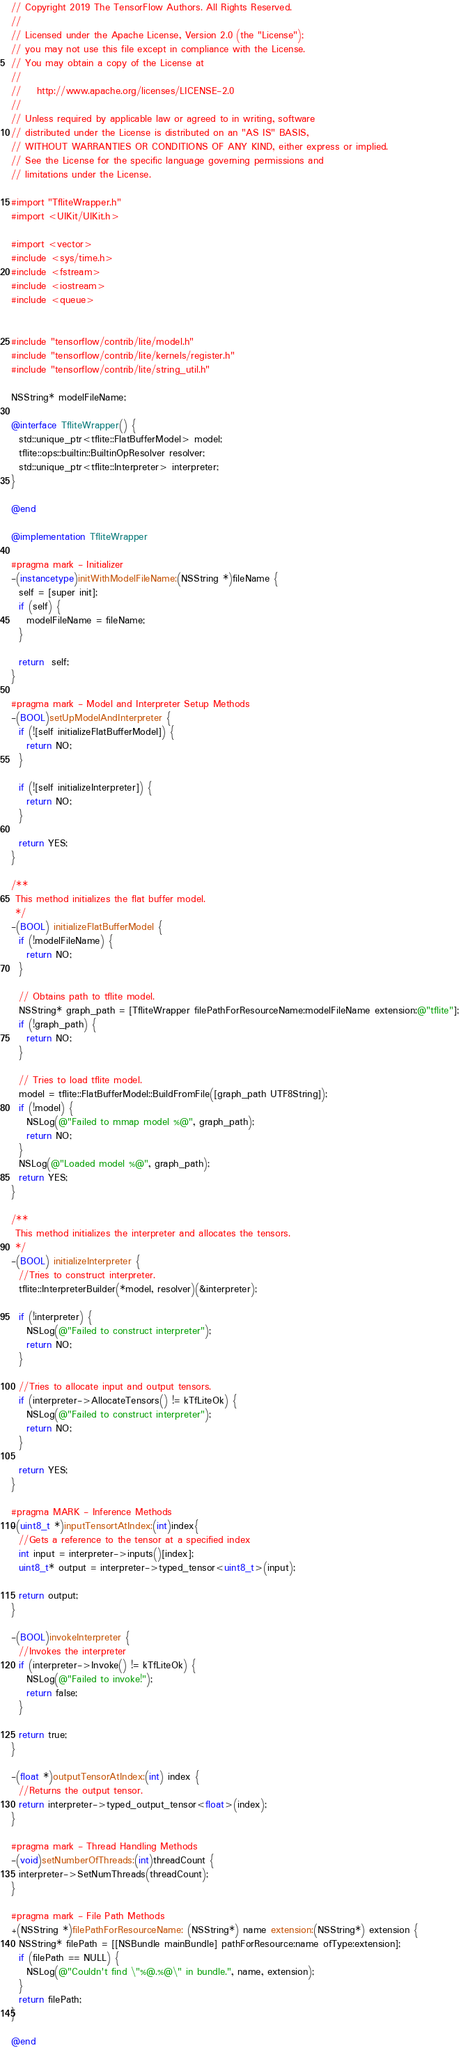Convert code to text. <code><loc_0><loc_0><loc_500><loc_500><_ObjectiveC_>// Copyright 2019 The TensorFlow Authors. All Rights Reserved.
//
// Licensed under the Apache License, Version 2.0 (the "License");
// you may not use this file except in compliance with the License.
// You may obtain a copy of the License at
//
//    http://www.apache.org/licenses/LICENSE-2.0
//
// Unless required by applicable law or agreed to in writing, software
// distributed under the License is distributed on an "AS IS" BASIS,
// WITHOUT WARRANTIES OR CONDITIONS OF ANY KIND, either express or implied.
// See the License for the specific language governing permissions and
// limitations under the License.

#import "TfliteWrapper.h"
#import <UIKit/UIKit.h>

#import <vector>
#include <sys/time.h>
#include <fstream>
#include <iostream>
#include <queue>


#include "tensorflow/contrib/lite/model.h"
#include "tensorflow/contrib/lite/kernels/register.h"
#include "tensorflow/contrib/lite/string_util.h"

NSString* modelFileName;

@interface TfliteWrapper() {
  std::unique_ptr<tflite::FlatBufferModel> model;
  tflite::ops::builtin::BuiltinOpResolver resolver;
  std::unique_ptr<tflite::Interpreter> interpreter;
}

@end

@implementation TfliteWrapper

#pragma mark - Initializer
-(instancetype)initWithModelFileName:(NSString *)fileName {
  self = [super init];
  if (self) {
    modelFileName = fileName;
  }

  return  self;
}

#pragma mark - Model and Interpreter Setup Methods
-(BOOL)setUpModelAndInterpreter {
  if (![self initializeFlatBufferModel]) {
    return NO;
  }

  if (![self initializeInterpreter]) {
    return NO;
  }

  return YES;
}

/**
 This method initializes the flat buffer model.
 */
-(BOOL) initializeFlatBufferModel {
  if (!modelFileName) {
    return NO;
  }

  // Obtains path to tflite model.
  NSString* graph_path = [TfliteWrapper filePathForResourceName:modelFileName extension:@"tflite"];
  if (!graph_path) {
    return NO;
  }

  // Tries to load tflite model.
  model = tflite::FlatBufferModel::BuildFromFile([graph_path UTF8String]);
  if (!model) {
    NSLog(@"Failed to mmap model %@", graph_path);
    return NO;
  }
  NSLog(@"Loaded model %@", graph_path);
  return YES;
}

/**
 This method initializes the interpreter and allocates the tensors.
 */
-(BOOL) initializeInterpreter {
  //Tries to construct interpreter.
  tflite::InterpreterBuilder(*model, resolver)(&interpreter);

  if (!interpreter) {
    NSLog(@"Failed to construct interpreter");
    return NO;
  }

  //Tries to allocate input and output tensors.
  if (interpreter->AllocateTensors() != kTfLiteOk) {
    NSLog(@"Failed to construct interpreter");
    return NO;
  }

  return YES;
}

#pragma MARK - Inference Methods
-(uint8_t *)inputTensortAtIndex:(int)index{
  //Gets a reference to the tensor at a specified index
  int input = interpreter->inputs()[index];
  uint8_t* output = interpreter->typed_tensor<uint8_t>(input);

  return output;
}

-(BOOL)invokeInterpreter {
  //Invokes the interpreter
  if (interpreter->Invoke() != kTfLiteOk) {
    NSLog(@"Failed to invoke!");
    return false;
  }

  return true;
}

-(float *)outputTensorAtIndex:(int) index {
  //Returns the output tensor.
  return interpreter->typed_output_tensor<float>(index);
}

#pragma mark - Thread Handling Methods
-(void)setNumberOfThreads:(int)threadCount {
  interpreter->SetNumThreads(threadCount);
}

#pragma mark - File Path Methods
+(NSString *)filePathForResourceName: (NSString*) name extension:(NSString*) extension {
  NSString* filePath = [[NSBundle mainBundle] pathForResource:name ofType:extension];
  if (filePath == NULL) {
    NSLog(@"Couldn't find \"%@.%@\" in bundle.", name, extension);
  }
  return filePath;
}

@end
</code> 